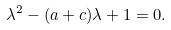<formula> <loc_0><loc_0><loc_500><loc_500>\lambda ^ { 2 } - ( a + c ) \lambda + 1 = 0 .</formula> 